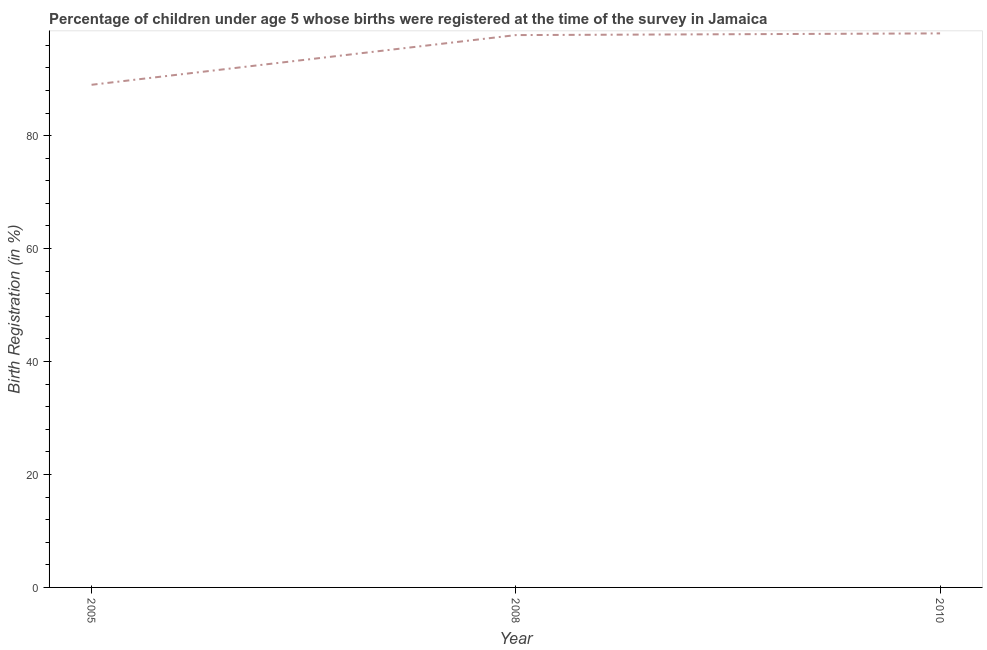What is the birth registration in 2008?
Offer a very short reply. 97.8. Across all years, what is the maximum birth registration?
Provide a short and direct response. 98.1. Across all years, what is the minimum birth registration?
Your response must be concise. 89. In which year was the birth registration maximum?
Provide a succinct answer. 2010. What is the sum of the birth registration?
Give a very brief answer. 284.9. What is the difference between the birth registration in 2005 and 2010?
Your answer should be very brief. -9.1. What is the average birth registration per year?
Your answer should be compact. 94.97. What is the median birth registration?
Ensure brevity in your answer.  97.8. In how many years, is the birth registration greater than 88 %?
Keep it short and to the point. 3. What is the ratio of the birth registration in 2008 to that in 2010?
Your response must be concise. 1. Is the birth registration in 2005 less than that in 2008?
Give a very brief answer. Yes. Is the difference between the birth registration in 2008 and 2010 greater than the difference between any two years?
Provide a short and direct response. No. What is the difference between the highest and the second highest birth registration?
Your response must be concise. 0.3. What is the difference between the highest and the lowest birth registration?
Offer a terse response. 9.1. In how many years, is the birth registration greater than the average birth registration taken over all years?
Give a very brief answer. 2. Does the birth registration monotonically increase over the years?
Give a very brief answer. Yes. Does the graph contain grids?
Keep it short and to the point. No. What is the title of the graph?
Provide a short and direct response. Percentage of children under age 5 whose births were registered at the time of the survey in Jamaica. What is the label or title of the X-axis?
Offer a very short reply. Year. What is the label or title of the Y-axis?
Offer a terse response. Birth Registration (in %). What is the Birth Registration (in %) of 2005?
Your answer should be very brief. 89. What is the Birth Registration (in %) of 2008?
Keep it short and to the point. 97.8. What is the Birth Registration (in %) of 2010?
Provide a short and direct response. 98.1. What is the difference between the Birth Registration (in %) in 2008 and 2010?
Keep it short and to the point. -0.3. What is the ratio of the Birth Registration (in %) in 2005 to that in 2008?
Offer a very short reply. 0.91. What is the ratio of the Birth Registration (in %) in 2005 to that in 2010?
Offer a very short reply. 0.91. 